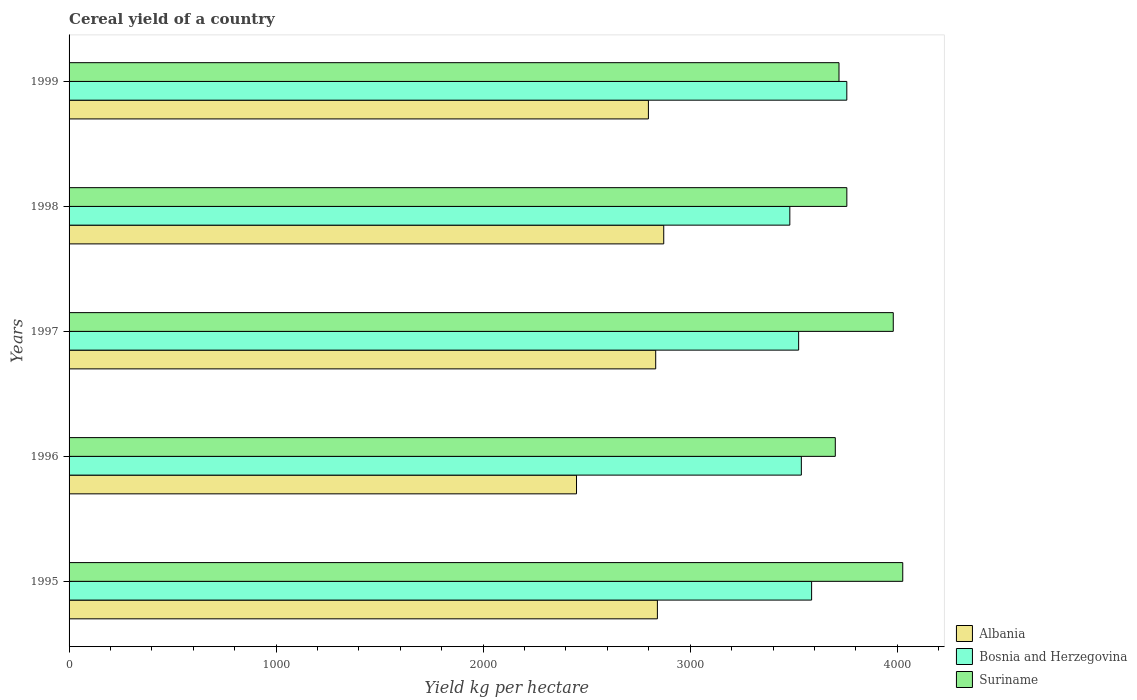How many different coloured bars are there?
Offer a terse response. 3. Are the number of bars per tick equal to the number of legend labels?
Your response must be concise. Yes. Are the number of bars on each tick of the Y-axis equal?
Your answer should be very brief. Yes. How many bars are there on the 2nd tick from the bottom?
Make the answer very short. 3. What is the total cereal yield in Albania in 1996?
Ensure brevity in your answer.  2450.85. Across all years, what is the maximum total cereal yield in Suriname?
Your response must be concise. 4026.52. Across all years, what is the minimum total cereal yield in Suriname?
Your answer should be compact. 3700.74. In which year was the total cereal yield in Albania maximum?
Your answer should be compact. 1998. In which year was the total cereal yield in Albania minimum?
Provide a short and direct response. 1996. What is the total total cereal yield in Suriname in the graph?
Offer a very short reply. 1.92e+04. What is the difference between the total cereal yield in Albania in 1995 and that in 1997?
Offer a terse response. 8.15. What is the difference between the total cereal yield in Bosnia and Herzegovina in 1996 and the total cereal yield in Albania in 1995?
Offer a terse response. 695.32. What is the average total cereal yield in Bosnia and Herzegovina per year?
Make the answer very short. 3576.87. In the year 1995, what is the difference between the total cereal yield in Suriname and total cereal yield in Bosnia and Herzegovina?
Offer a terse response. 440.19. In how many years, is the total cereal yield in Albania greater than 4000 kg per hectare?
Give a very brief answer. 0. What is the ratio of the total cereal yield in Albania in 1995 to that in 1999?
Give a very brief answer. 1.02. What is the difference between the highest and the second highest total cereal yield in Bosnia and Herzegovina?
Offer a very short reply. 170.03. What is the difference between the highest and the lowest total cereal yield in Suriname?
Provide a short and direct response. 325.77. Is the sum of the total cereal yield in Albania in 1996 and 1998 greater than the maximum total cereal yield in Suriname across all years?
Provide a short and direct response. Yes. What does the 2nd bar from the top in 1997 represents?
Give a very brief answer. Bosnia and Herzegovina. What does the 1st bar from the bottom in 1997 represents?
Your answer should be compact. Albania. Are all the bars in the graph horizontal?
Provide a short and direct response. Yes. How many years are there in the graph?
Make the answer very short. 5. What is the difference between two consecutive major ticks on the X-axis?
Ensure brevity in your answer.  1000. Does the graph contain any zero values?
Provide a succinct answer. No. Does the graph contain grids?
Your answer should be very brief. No. Where does the legend appear in the graph?
Make the answer very short. Bottom right. What is the title of the graph?
Keep it short and to the point. Cereal yield of a country. Does "Russian Federation" appear as one of the legend labels in the graph?
Your answer should be very brief. No. What is the label or title of the X-axis?
Offer a very short reply. Yield kg per hectare. What is the Yield kg per hectare in Albania in 1995?
Provide a succinct answer. 2841.46. What is the Yield kg per hectare of Bosnia and Herzegovina in 1995?
Provide a short and direct response. 3586.32. What is the Yield kg per hectare in Suriname in 1995?
Your answer should be compact. 4026.52. What is the Yield kg per hectare of Albania in 1996?
Offer a very short reply. 2450.85. What is the Yield kg per hectare in Bosnia and Herzegovina in 1996?
Keep it short and to the point. 3536.78. What is the Yield kg per hectare in Suriname in 1996?
Provide a short and direct response. 3700.74. What is the Yield kg per hectare of Albania in 1997?
Your answer should be compact. 2833.3. What is the Yield kg per hectare of Bosnia and Herzegovina in 1997?
Make the answer very short. 3523.74. What is the Yield kg per hectare in Suriname in 1997?
Provide a succinct answer. 3980.71. What is the Yield kg per hectare of Albania in 1998?
Your answer should be compact. 2872.11. What is the Yield kg per hectare in Bosnia and Herzegovina in 1998?
Give a very brief answer. 3481.17. What is the Yield kg per hectare in Suriname in 1998?
Your response must be concise. 3756.5. What is the Yield kg per hectare of Albania in 1999?
Give a very brief answer. 2798.09. What is the Yield kg per hectare of Bosnia and Herzegovina in 1999?
Offer a very short reply. 3756.35. What is the Yield kg per hectare of Suriname in 1999?
Give a very brief answer. 3718.66. Across all years, what is the maximum Yield kg per hectare in Albania?
Give a very brief answer. 2872.11. Across all years, what is the maximum Yield kg per hectare of Bosnia and Herzegovina?
Offer a very short reply. 3756.35. Across all years, what is the maximum Yield kg per hectare of Suriname?
Your answer should be very brief. 4026.52. Across all years, what is the minimum Yield kg per hectare of Albania?
Provide a succinct answer. 2450.85. Across all years, what is the minimum Yield kg per hectare of Bosnia and Herzegovina?
Your answer should be very brief. 3481.17. Across all years, what is the minimum Yield kg per hectare of Suriname?
Offer a terse response. 3700.74. What is the total Yield kg per hectare of Albania in the graph?
Your response must be concise. 1.38e+04. What is the total Yield kg per hectare of Bosnia and Herzegovina in the graph?
Provide a short and direct response. 1.79e+04. What is the total Yield kg per hectare of Suriname in the graph?
Provide a short and direct response. 1.92e+04. What is the difference between the Yield kg per hectare of Albania in 1995 and that in 1996?
Keep it short and to the point. 390.6. What is the difference between the Yield kg per hectare in Bosnia and Herzegovina in 1995 and that in 1996?
Provide a succinct answer. 49.55. What is the difference between the Yield kg per hectare of Suriname in 1995 and that in 1996?
Provide a short and direct response. 325.77. What is the difference between the Yield kg per hectare of Albania in 1995 and that in 1997?
Your response must be concise. 8.15. What is the difference between the Yield kg per hectare of Bosnia and Herzegovina in 1995 and that in 1997?
Provide a succinct answer. 62.58. What is the difference between the Yield kg per hectare of Suriname in 1995 and that in 1997?
Give a very brief answer. 45.81. What is the difference between the Yield kg per hectare of Albania in 1995 and that in 1998?
Your answer should be very brief. -30.66. What is the difference between the Yield kg per hectare in Bosnia and Herzegovina in 1995 and that in 1998?
Make the answer very short. 105.16. What is the difference between the Yield kg per hectare in Suriname in 1995 and that in 1998?
Provide a succinct answer. 270.02. What is the difference between the Yield kg per hectare of Albania in 1995 and that in 1999?
Your answer should be very brief. 43.37. What is the difference between the Yield kg per hectare in Bosnia and Herzegovina in 1995 and that in 1999?
Make the answer very short. -170.03. What is the difference between the Yield kg per hectare in Suriname in 1995 and that in 1999?
Offer a terse response. 307.86. What is the difference between the Yield kg per hectare of Albania in 1996 and that in 1997?
Ensure brevity in your answer.  -382.45. What is the difference between the Yield kg per hectare in Bosnia and Herzegovina in 1996 and that in 1997?
Your response must be concise. 13.04. What is the difference between the Yield kg per hectare in Suriname in 1996 and that in 1997?
Offer a very short reply. -279.97. What is the difference between the Yield kg per hectare of Albania in 1996 and that in 1998?
Offer a terse response. -421.26. What is the difference between the Yield kg per hectare in Bosnia and Herzegovina in 1996 and that in 1998?
Make the answer very short. 55.61. What is the difference between the Yield kg per hectare in Suriname in 1996 and that in 1998?
Give a very brief answer. -55.76. What is the difference between the Yield kg per hectare of Albania in 1996 and that in 1999?
Your response must be concise. -347.24. What is the difference between the Yield kg per hectare of Bosnia and Herzegovina in 1996 and that in 1999?
Keep it short and to the point. -219.57. What is the difference between the Yield kg per hectare in Suriname in 1996 and that in 1999?
Provide a succinct answer. -17.92. What is the difference between the Yield kg per hectare of Albania in 1997 and that in 1998?
Offer a terse response. -38.81. What is the difference between the Yield kg per hectare in Bosnia and Herzegovina in 1997 and that in 1998?
Give a very brief answer. 42.57. What is the difference between the Yield kg per hectare in Suriname in 1997 and that in 1998?
Give a very brief answer. 224.21. What is the difference between the Yield kg per hectare in Albania in 1997 and that in 1999?
Give a very brief answer. 35.22. What is the difference between the Yield kg per hectare in Bosnia and Herzegovina in 1997 and that in 1999?
Offer a terse response. -232.61. What is the difference between the Yield kg per hectare in Suriname in 1997 and that in 1999?
Your answer should be very brief. 262.05. What is the difference between the Yield kg per hectare of Albania in 1998 and that in 1999?
Your response must be concise. 74.03. What is the difference between the Yield kg per hectare in Bosnia and Herzegovina in 1998 and that in 1999?
Keep it short and to the point. -275.18. What is the difference between the Yield kg per hectare of Suriname in 1998 and that in 1999?
Provide a short and direct response. 37.84. What is the difference between the Yield kg per hectare in Albania in 1995 and the Yield kg per hectare in Bosnia and Herzegovina in 1996?
Provide a short and direct response. -695.32. What is the difference between the Yield kg per hectare of Albania in 1995 and the Yield kg per hectare of Suriname in 1996?
Provide a short and direct response. -859.29. What is the difference between the Yield kg per hectare in Bosnia and Herzegovina in 1995 and the Yield kg per hectare in Suriname in 1996?
Offer a terse response. -114.42. What is the difference between the Yield kg per hectare of Albania in 1995 and the Yield kg per hectare of Bosnia and Herzegovina in 1997?
Your response must be concise. -682.28. What is the difference between the Yield kg per hectare of Albania in 1995 and the Yield kg per hectare of Suriname in 1997?
Make the answer very short. -1139.25. What is the difference between the Yield kg per hectare of Bosnia and Herzegovina in 1995 and the Yield kg per hectare of Suriname in 1997?
Offer a terse response. -394.39. What is the difference between the Yield kg per hectare in Albania in 1995 and the Yield kg per hectare in Bosnia and Herzegovina in 1998?
Give a very brief answer. -639.71. What is the difference between the Yield kg per hectare in Albania in 1995 and the Yield kg per hectare in Suriname in 1998?
Offer a very short reply. -915.04. What is the difference between the Yield kg per hectare of Bosnia and Herzegovina in 1995 and the Yield kg per hectare of Suriname in 1998?
Make the answer very short. -170.18. What is the difference between the Yield kg per hectare of Albania in 1995 and the Yield kg per hectare of Bosnia and Herzegovina in 1999?
Make the answer very short. -914.89. What is the difference between the Yield kg per hectare in Albania in 1995 and the Yield kg per hectare in Suriname in 1999?
Your response must be concise. -877.2. What is the difference between the Yield kg per hectare of Bosnia and Herzegovina in 1995 and the Yield kg per hectare of Suriname in 1999?
Provide a succinct answer. -132.34. What is the difference between the Yield kg per hectare of Albania in 1996 and the Yield kg per hectare of Bosnia and Herzegovina in 1997?
Provide a short and direct response. -1072.89. What is the difference between the Yield kg per hectare in Albania in 1996 and the Yield kg per hectare in Suriname in 1997?
Provide a succinct answer. -1529.86. What is the difference between the Yield kg per hectare in Bosnia and Herzegovina in 1996 and the Yield kg per hectare in Suriname in 1997?
Offer a very short reply. -443.93. What is the difference between the Yield kg per hectare in Albania in 1996 and the Yield kg per hectare in Bosnia and Herzegovina in 1998?
Keep it short and to the point. -1030.32. What is the difference between the Yield kg per hectare in Albania in 1996 and the Yield kg per hectare in Suriname in 1998?
Your response must be concise. -1305.65. What is the difference between the Yield kg per hectare of Bosnia and Herzegovina in 1996 and the Yield kg per hectare of Suriname in 1998?
Provide a short and direct response. -219.72. What is the difference between the Yield kg per hectare in Albania in 1996 and the Yield kg per hectare in Bosnia and Herzegovina in 1999?
Your answer should be compact. -1305.5. What is the difference between the Yield kg per hectare in Albania in 1996 and the Yield kg per hectare in Suriname in 1999?
Give a very brief answer. -1267.81. What is the difference between the Yield kg per hectare in Bosnia and Herzegovina in 1996 and the Yield kg per hectare in Suriname in 1999?
Your response must be concise. -181.88. What is the difference between the Yield kg per hectare in Albania in 1997 and the Yield kg per hectare in Bosnia and Herzegovina in 1998?
Give a very brief answer. -647.87. What is the difference between the Yield kg per hectare of Albania in 1997 and the Yield kg per hectare of Suriname in 1998?
Your response must be concise. -923.2. What is the difference between the Yield kg per hectare of Bosnia and Herzegovina in 1997 and the Yield kg per hectare of Suriname in 1998?
Keep it short and to the point. -232.76. What is the difference between the Yield kg per hectare of Albania in 1997 and the Yield kg per hectare of Bosnia and Herzegovina in 1999?
Give a very brief answer. -923.05. What is the difference between the Yield kg per hectare in Albania in 1997 and the Yield kg per hectare in Suriname in 1999?
Your answer should be compact. -885.36. What is the difference between the Yield kg per hectare in Bosnia and Herzegovina in 1997 and the Yield kg per hectare in Suriname in 1999?
Provide a succinct answer. -194.92. What is the difference between the Yield kg per hectare in Albania in 1998 and the Yield kg per hectare in Bosnia and Herzegovina in 1999?
Ensure brevity in your answer.  -884.24. What is the difference between the Yield kg per hectare of Albania in 1998 and the Yield kg per hectare of Suriname in 1999?
Offer a terse response. -846.55. What is the difference between the Yield kg per hectare in Bosnia and Herzegovina in 1998 and the Yield kg per hectare in Suriname in 1999?
Provide a succinct answer. -237.49. What is the average Yield kg per hectare of Albania per year?
Your response must be concise. 2759.16. What is the average Yield kg per hectare of Bosnia and Herzegovina per year?
Offer a terse response. 3576.87. What is the average Yield kg per hectare in Suriname per year?
Ensure brevity in your answer.  3836.63. In the year 1995, what is the difference between the Yield kg per hectare in Albania and Yield kg per hectare in Bosnia and Herzegovina?
Ensure brevity in your answer.  -744.87. In the year 1995, what is the difference between the Yield kg per hectare of Albania and Yield kg per hectare of Suriname?
Make the answer very short. -1185.06. In the year 1995, what is the difference between the Yield kg per hectare of Bosnia and Herzegovina and Yield kg per hectare of Suriname?
Your response must be concise. -440.19. In the year 1996, what is the difference between the Yield kg per hectare of Albania and Yield kg per hectare of Bosnia and Herzegovina?
Your answer should be compact. -1085.93. In the year 1996, what is the difference between the Yield kg per hectare in Albania and Yield kg per hectare in Suriname?
Ensure brevity in your answer.  -1249.89. In the year 1996, what is the difference between the Yield kg per hectare of Bosnia and Herzegovina and Yield kg per hectare of Suriname?
Your answer should be very brief. -163.96. In the year 1997, what is the difference between the Yield kg per hectare of Albania and Yield kg per hectare of Bosnia and Herzegovina?
Your answer should be very brief. -690.44. In the year 1997, what is the difference between the Yield kg per hectare in Albania and Yield kg per hectare in Suriname?
Make the answer very short. -1147.41. In the year 1997, what is the difference between the Yield kg per hectare in Bosnia and Herzegovina and Yield kg per hectare in Suriname?
Provide a succinct answer. -456.97. In the year 1998, what is the difference between the Yield kg per hectare of Albania and Yield kg per hectare of Bosnia and Herzegovina?
Your response must be concise. -609.06. In the year 1998, what is the difference between the Yield kg per hectare of Albania and Yield kg per hectare of Suriname?
Provide a succinct answer. -884.39. In the year 1998, what is the difference between the Yield kg per hectare of Bosnia and Herzegovina and Yield kg per hectare of Suriname?
Keep it short and to the point. -275.33. In the year 1999, what is the difference between the Yield kg per hectare in Albania and Yield kg per hectare in Bosnia and Herzegovina?
Make the answer very short. -958.26. In the year 1999, what is the difference between the Yield kg per hectare in Albania and Yield kg per hectare in Suriname?
Your answer should be very brief. -920.57. In the year 1999, what is the difference between the Yield kg per hectare of Bosnia and Herzegovina and Yield kg per hectare of Suriname?
Give a very brief answer. 37.69. What is the ratio of the Yield kg per hectare in Albania in 1995 to that in 1996?
Make the answer very short. 1.16. What is the ratio of the Yield kg per hectare of Bosnia and Herzegovina in 1995 to that in 1996?
Your response must be concise. 1.01. What is the ratio of the Yield kg per hectare of Suriname in 1995 to that in 1996?
Offer a very short reply. 1.09. What is the ratio of the Yield kg per hectare of Albania in 1995 to that in 1997?
Provide a short and direct response. 1. What is the ratio of the Yield kg per hectare of Bosnia and Herzegovina in 1995 to that in 1997?
Provide a short and direct response. 1.02. What is the ratio of the Yield kg per hectare of Suriname in 1995 to that in 1997?
Your answer should be compact. 1.01. What is the ratio of the Yield kg per hectare in Albania in 1995 to that in 1998?
Keep it short and to the point. 0.99. What is the ratio of the Yield kg per hectare in Bosnia and Herzegovina in 1995 to that in 1998?
Provide a short and direct response. 1.03. What is the ratio of the Yield kg per hectare in Suriname in 1995 to that in 1998?
Keep it short and to the point. 1.07. What is the ratio of the Yield kg per hectare in Albania in 1995 to that in 1999?
Provide a succinct answer. 1.02. What is the ratio of the Yield kg per hectare of Bosnia and Herzegovina in 1995 to that in 1999?
Provide a succinct answer. 0.95. What is the ratio of the Yield kg per hectare in Suriname in 1995 to that in 1999?
Provide a succinct answer. 1.08. What is the ratio of the Yield kg per hectare in Albania in 1996 to that in 1997?
Offer a terse response. 0.86. What is the ratio of the Yield kg per hectare in Bosnia and Herzegovina in 1996 to that in 1997?
Offer a very short reply. 1. What is the ratio of the Yield kg per hectare of Suriname in 1996 to that in 1997?
Your answer should be compact. 0.93. What is the ratio of the Yield kg per hectare of Albania in 1996 to that in 1998?
Provide a succinct answer. 0.85. What is the ratio of the Yield kg per hectare of Bosnia and Herzegovina in 1996 to that in 1998?
Offer a terse response. 1.02. What is the ratio of the Yield kg per hectare in Suriname in 1996 to that in 1998?
Your answer should be compact. 0.99. What is the ratio of the Yield kg per hectare of Albania in 1996 to that in 1999?
Make the answer very short. 0.88. What is the ratio of the Yield kg per hectare of Bosnia and Herzegovina in 1996 to that in 1999?
Your response must be concise. 0.94. What is the ratio of the Yield kg per hectare of Suriname in 1996 to that in 1999?
Provide a short and direct response. 1. What is the ratio of the Yield kg per hectare of Albania in 1997 to that in 1998?
Give a very brief answer. 0.99. What is the ratio of the Yield kg per hectare of Bosnia and Herzegovina in 1997 to that in 1998?
Your answer should be compact. 1.01. What is the ratio of the Yield kg per hectare in Suriname in 1997 to that in 1998?
Provide a succinct answer. 1.06. What is the ratio of the Yield kg per hectare of Albania in 1997 to that in 1999?
Offer a terse response. 1.01. What is the ratio of the Yield kg per hectare of Bosnia and Herzegovina in 1997 to that in 1999?
Ensure brevity in your answer.  0.94. What is the ratio of the Yield kg per hectare of Suriname in 1997 to that in 1999?
Your response must be concise. 1.07. What is the ratio of the Yield kg per hectare in Albania in 1998 to that in 1999?
Give a very brief answer. 1.03. What is the ratio of the Yield kg per hectare in Bosnia and Herzegovina in 1998 to that in 1999?
Offer a very short reply. 0.93. What is the ratio of the Yield kg per hectare in Suriname in 1998 to that in 1999?
Give a very brief answer. 1.01. What is the difference between the highest and the second highest Yield kg per hectare of Albania?
Ensure brevity in your answer.  30.66. What is the difference between the highest and the second highest Yield kg per hectare in Bosnia and Herzegovina?
Ensure brevity in your answer.  170.03. What is the difference between the highest and the second highest Yield kg per hectare of Suriname?
Provide a short and direct response. 45.81. What is the difference between the highest and the lowest Yield kg per hectare in Albania?
Your response must be concise. 421.26. What is the difference between the highest and the lowest Yield kg per hectare in Bosnia and Herzegovina?
Give a very brief answer. 275.18. What is the difference between the highest and the lowest Yield kg per hectare in Suriname?
Make the answer very short. 325.77. 